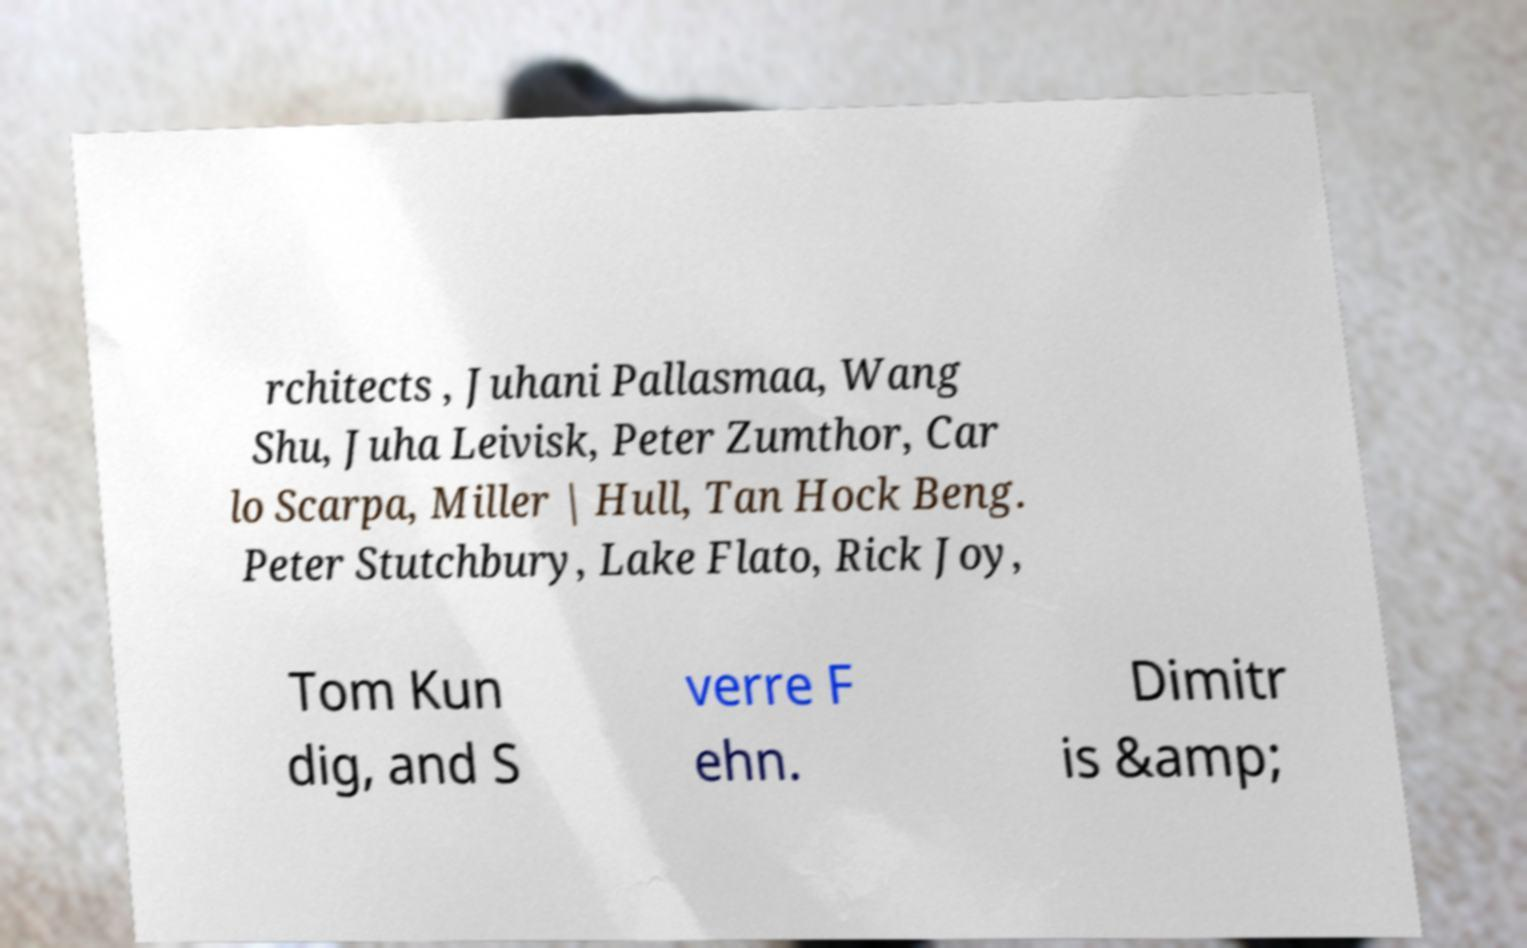Please read and relay the text visible in this image. What does it say? rchitects , Juhani Pallasmaa, Wang Shu, Juha Leivisk, Peter Zumthor, Car lo Scarpa, Miller | Hull, Tan Hock Beng. Peter Stutchbury, Lake Flato, Rick Joy, Tom Kun dig, and S verre F ehn. Dimitr is &amp; 